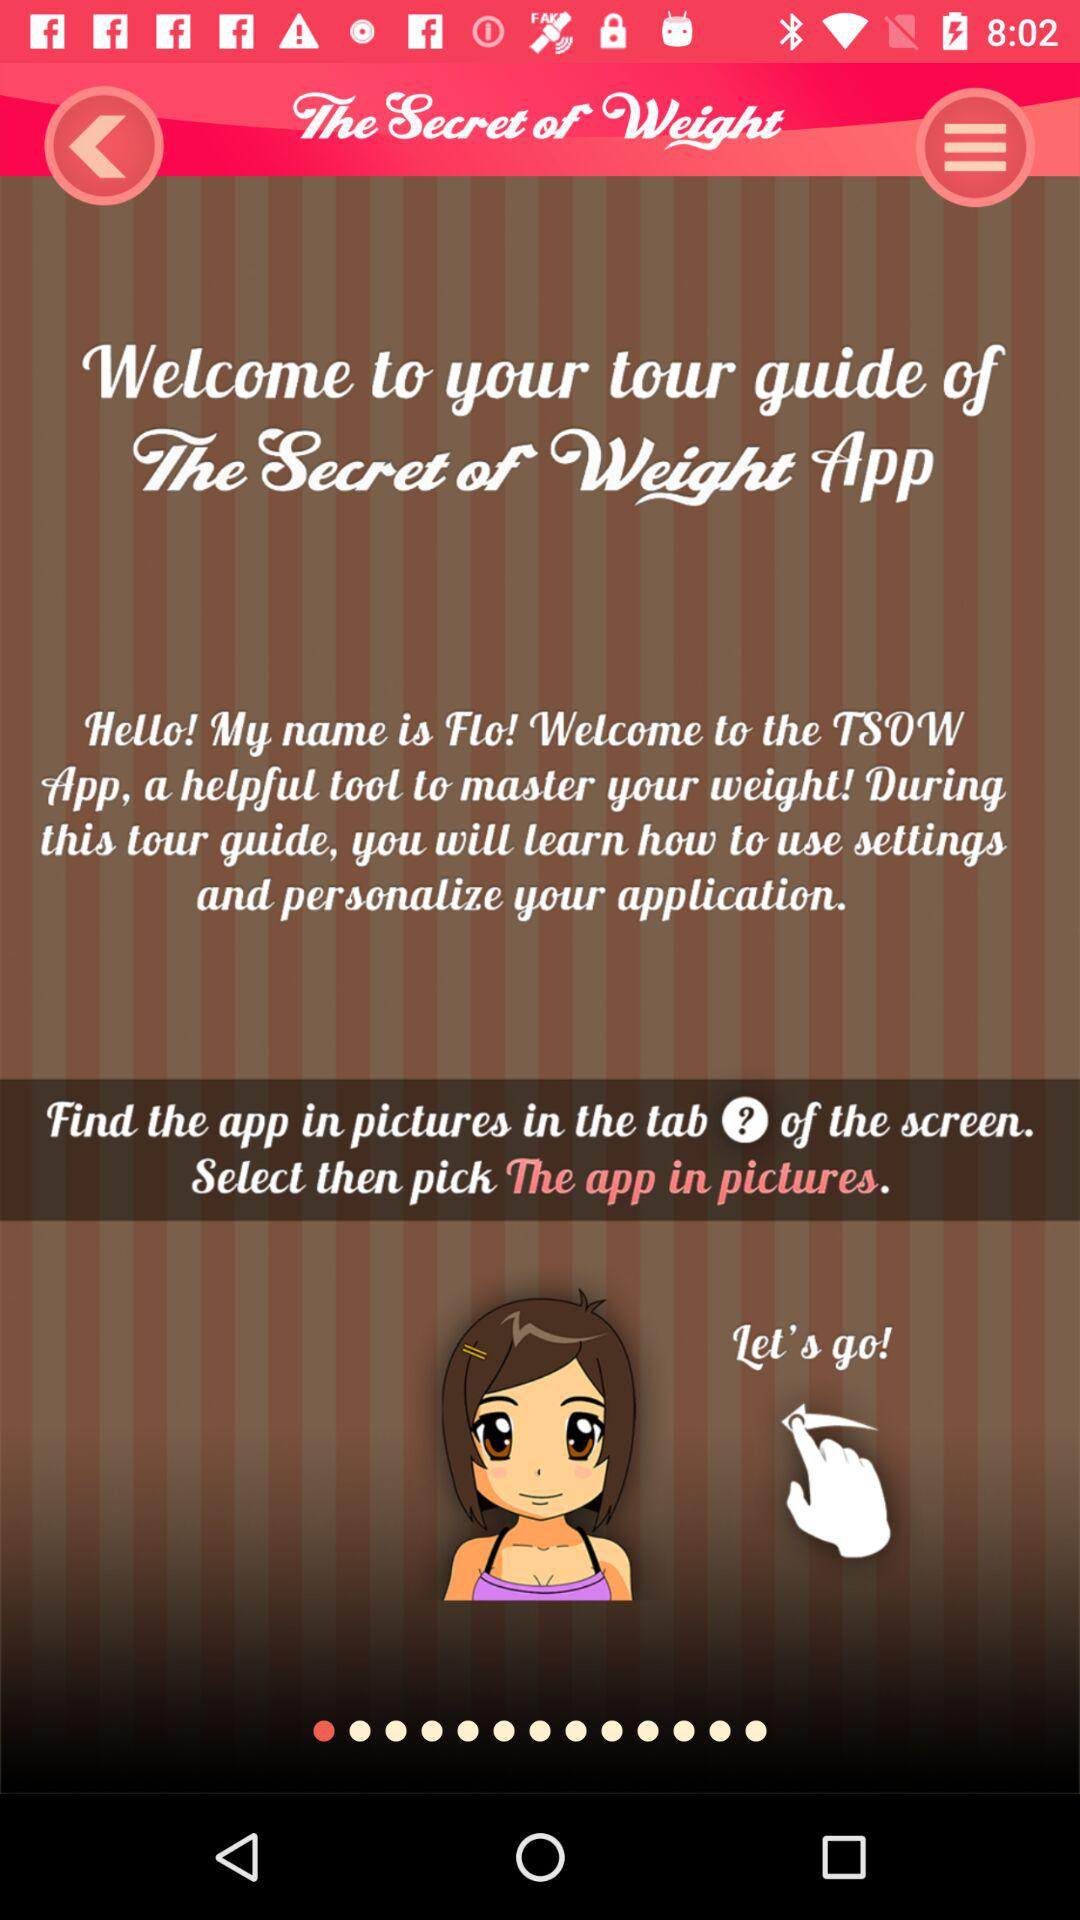What is the name of the user?
When the provided information is insufficient, respond with <no answer>. <no answer> 